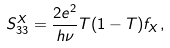Convert formula to latex. <formula><loc_0><loc_0><loc_500><loc_500>S _ { 3 3 } ^ { X } = \frac { 2 e ^ { 2 } } { h \nu } T ( 1 - T ) f _ { X } ,</formula> 